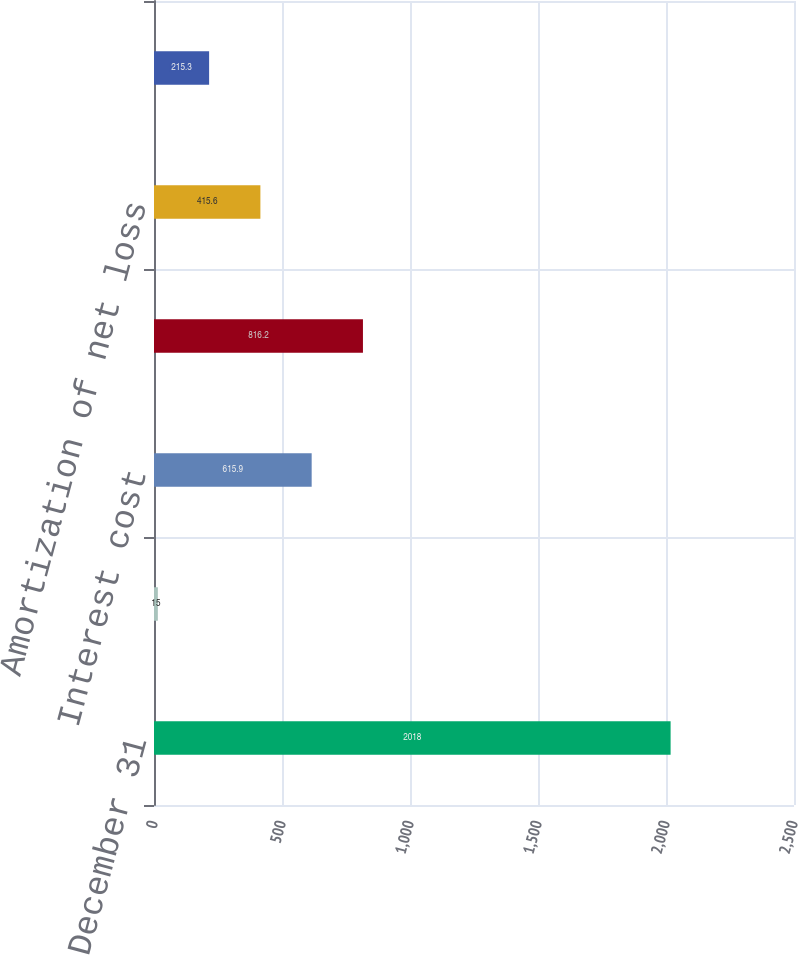Convert chart to OTSL. <chart><loc_0><loc_0><loc_500><loc_500><bar_chart><fcel>December 31<fcel>Service cost<fcel>Interest cost<fcel>Expected return on plan assets<fcel>Amortization of net loss<fcel>Total pension cost<nl><fcel>2018<fcel>15<fcel>615.9<fcel>816.2<fcel>415.6<fcel>215.3<nl></chart> 